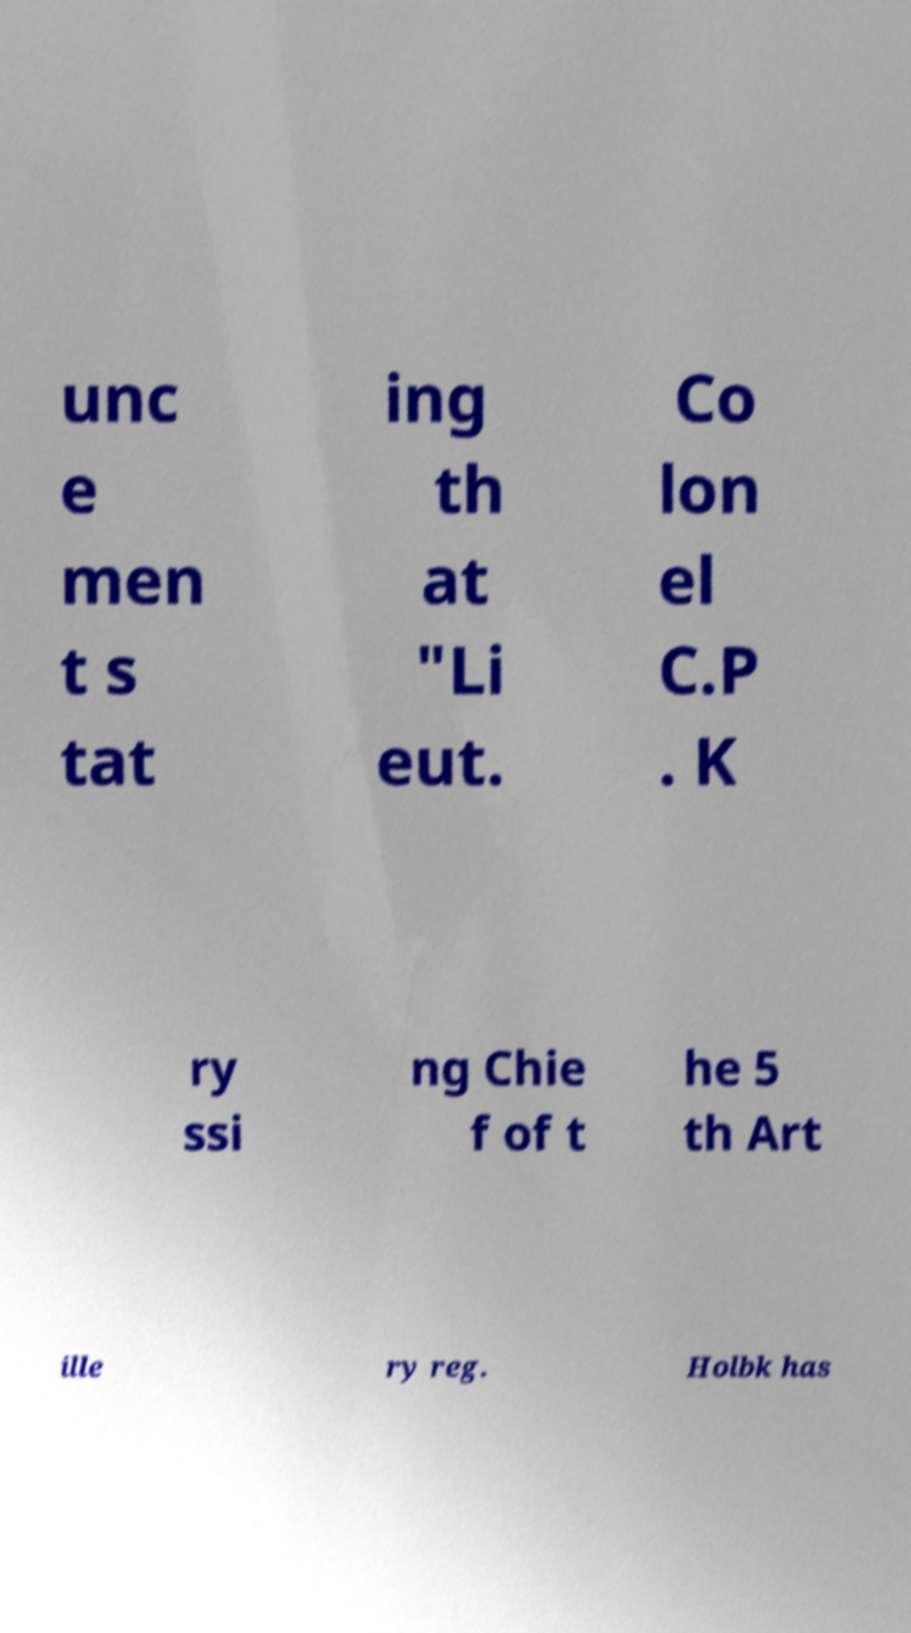Please read and relay the text visible in this image. What does it say? unc e men t s tat ing th at "Li eut. Co lon el C.P . K ry ssi ng Chie f of t he 5 th Art ille ry reg. Holbk has 